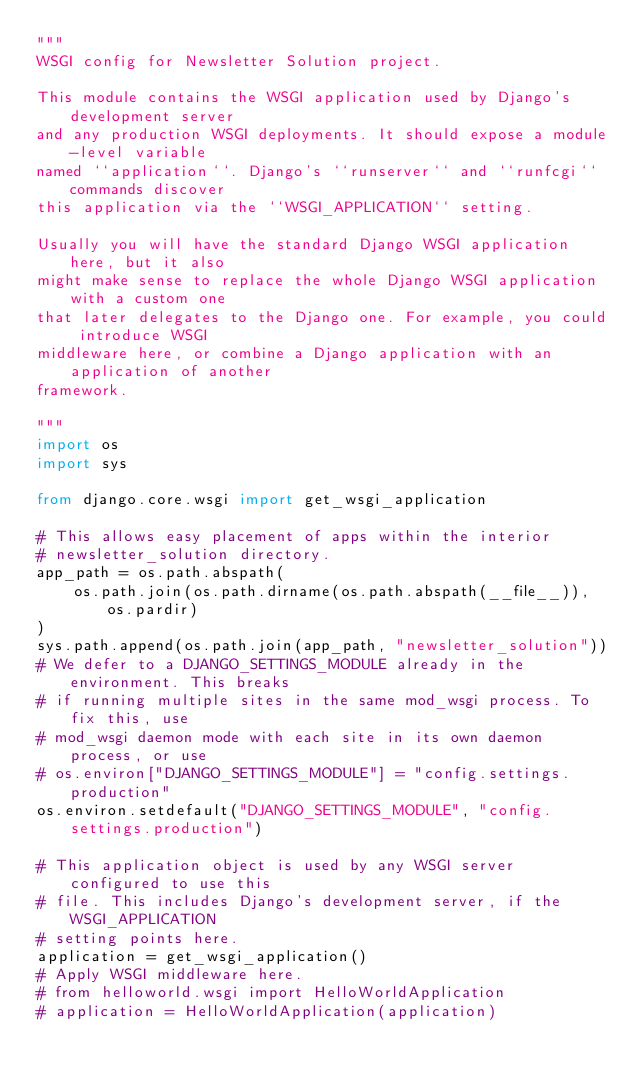Convert code to text. <code><loc_0><loc_0><loc_500><loc_500><_Python_>"""
WSGI config for Newsletter Solution project.

This module contains the WSGI application used by Django's development server
and any production WSGI deployments. It should expose a module-level variable
named ``application``. Django's ``runserver`` and ``runfcgi`` commands discover
this application via the ``WSGI_APPLICATION`` setting.

Usually you will have the standard Django WSGI application here, but it also
might make sense to replace the whole Django WSGI application with a custom one
that later delegates to the Django one. For example, you could introduce WSGI
middleware here, or combine a Django application with an application of another
framework.

"""
import os
import sys

from django.core.wsgi import get_wsgi_application

# This allows easy placement of apps within the interior
# newsletter_solution directory.
app_path = os.path.abspath(
    os.path.join(os.path.dirname(os.path.abspath(__file__)), os.pardir)
)
sys.path.append(os.path.join(app_path, "newsletter_solution"))
# We defer to a DJANGO_SETTINGS_MODULE already in the environment. This breaks
# if running multiple sites in the same mod_wsgi process. To fix this, use
# mod_wsgi daemon mode with each site in its own daemon process, or use
# os.environ["DJANGO_SETTINGS_MODULE"] = "config.settings.production"
os.environ.setdefault("DJANGO_SETTINGS_MODULE", "config.settings.production")

# This application object is used by any WSGI server configured to use this
# file. This includes Django's development server, if the WSGI_APPLICATION
# setting points here.
application = get_wsgi_application()
# Apply WSGI middleware here.
# from helloworld.wsgi import HelloWorldApplication
# application = HelloWorldApplication(application)
</code> 